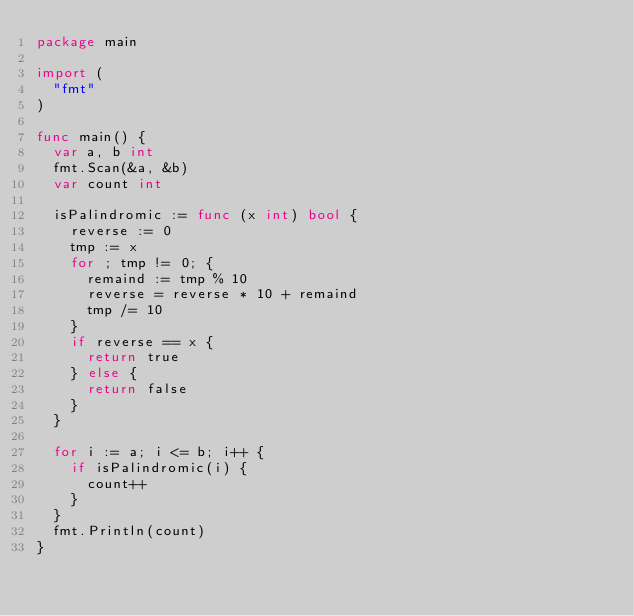Convert code to text. <code><loc_0><loc_0><loc_500><loc_500><_Go_>package main

import (
	"fmt"
)

func main() {
	var a, b int
	fmt.Scan(&a, &b)
	var count int

	isPalindromic := func (x int) bool {
		reverse := 0
		tmp := x
		for ; tmp != 0; {
			remaind := tmp % 10
			reverse = reverse * 10 + remaind
			tmp /= 10
		}
		if reverse == x {
			return true
		} else {
			return false
		}
	}

	for i := a; i <= b; i++ {
		if isPalindromic(i) {
			count++
		}
	}
	fmt.Println(count)
}
</code> 